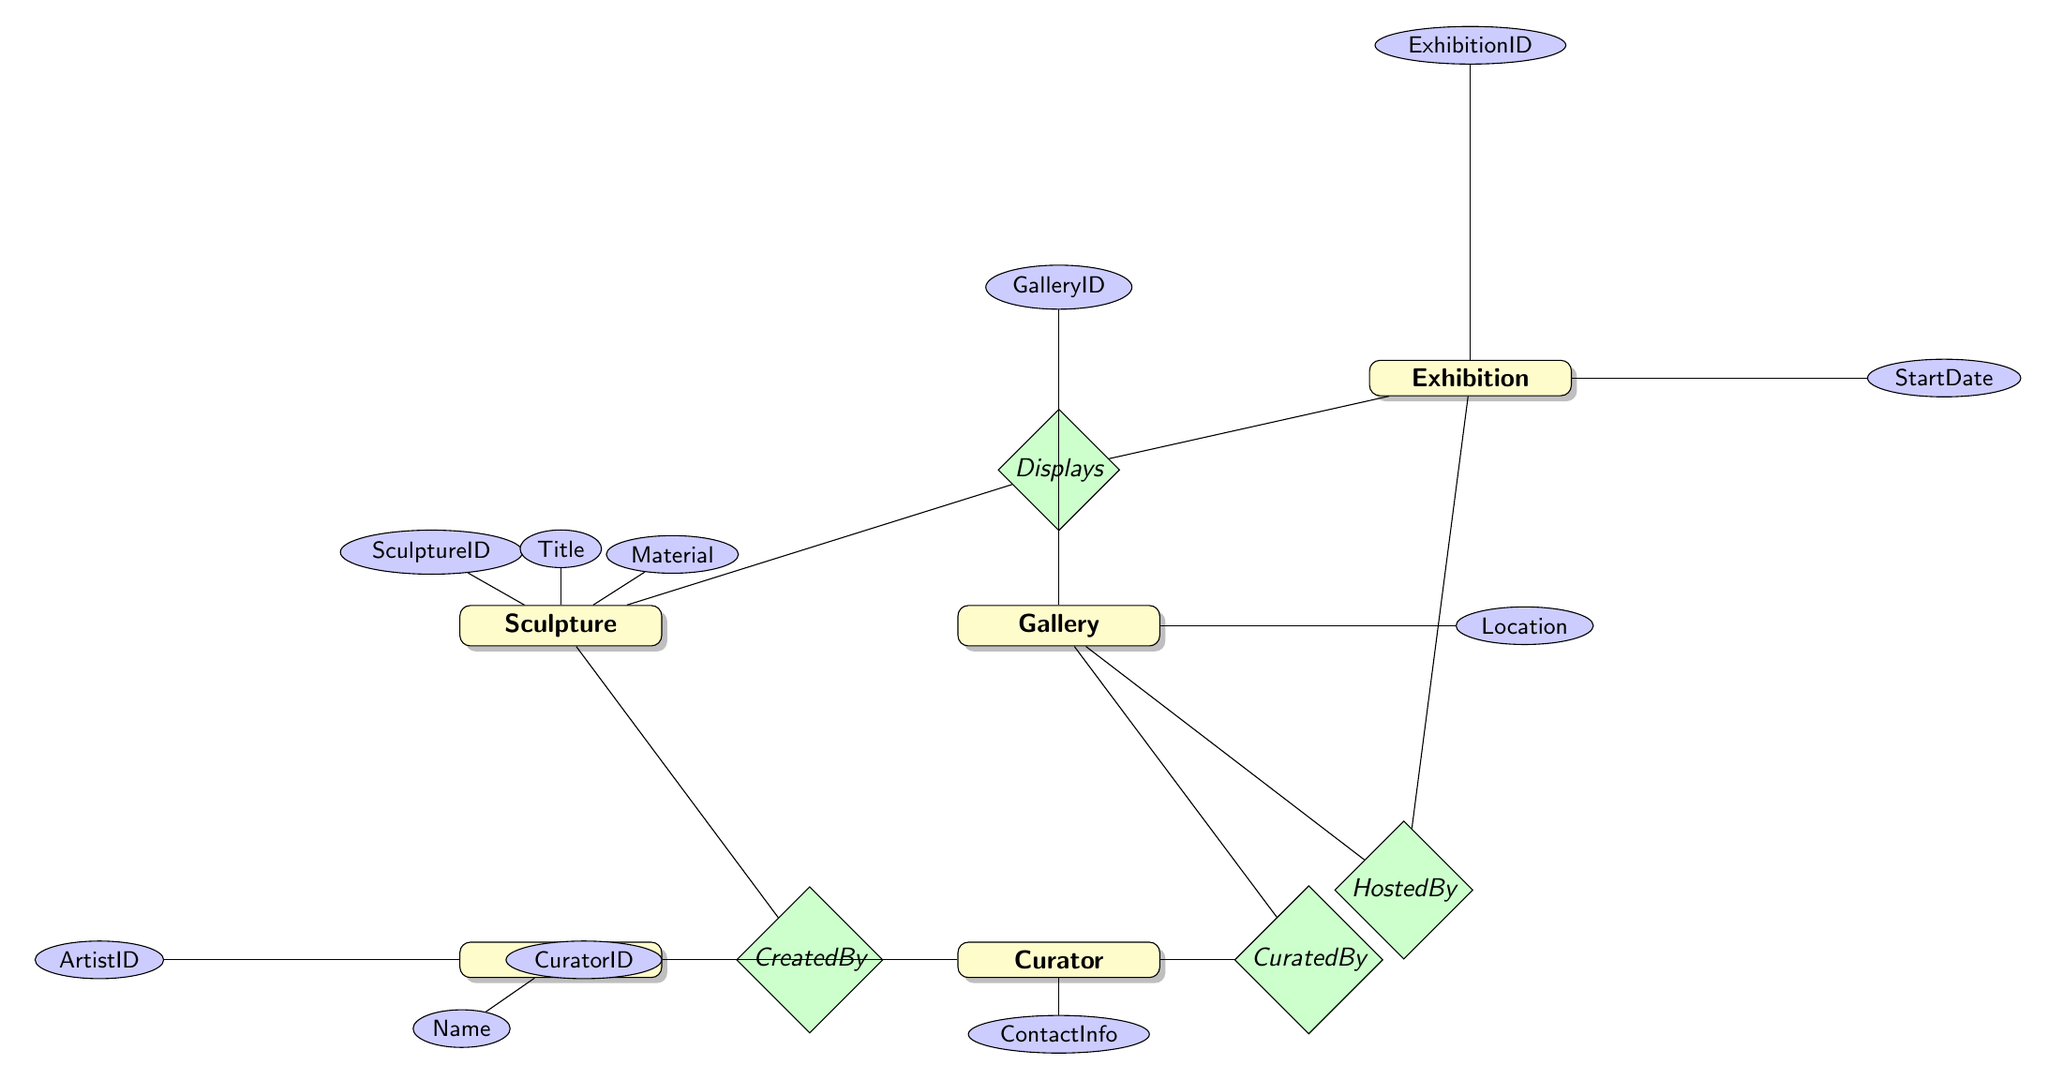What is the primary key for the Sculpture entity? The primary key for the Sculpture entity is indicated by the attribute "SculptureID" which uniquely identifies each sculpture.
Answer: SculptureID Who curates the Gallery? The relationship between the Gallery and Curator entities indicates a one-to-one relationship from Gallery to Curator, where the Curator is responsible for the Gallery.
Answer: Curator How many entities are displayed in the Exhibition? The "Displays" relationship shows that an Exhibition can display multiple Sculptures, which implies there can be many entries in this relationship.
Answer: Many What is the start date of the Exhibition? The Exhibition entity has an attribute "StartDate" that provides the specific date the exhibition commences.
Answer: StartDate Which entity has the attribute "ContactInfo"? The attribute "ContactInfo" is associated with the Curator entity as indicated in the diagram.
Answer: Curator What type of relationship exists between Sculpture and Artist? The relationship named "CreatedBy" connects Sculpture to Artist, defining that many sculptures can be created by one artist.
Answer: Many-to-one How many attributes does the Gallery entity have? The Gallery entity displays a total of four attributes: GalleryID, Name, Location, and CuratorID, resulting in a count of four.
Answer: Four Which entity is the host for the Exhibition? The "HostedBy" relationship highlights that the Exhibition is hosted by the Gallery, meaning the Gallery entity is the one that holds the Exhibition.
Answer: Gallery What does the relationship “Displays” represent? The "Displays" relationship represents the many-to-many connection between Exhibition and Sculpture, indicating that an exhibition can display multiple sculptures and sculptures can be part of multiple exhibitions.
Answer: Many-to-many 